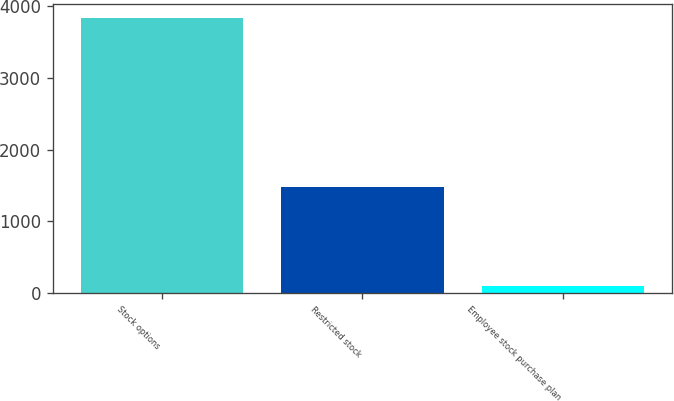Convert chart. <chart><loc_0><loc_0><loc_500><loc_500><bar_chart><fcel>Stock options<fcel>Restricted stock<fcel>Employee stock purchase plan<nl><fcel>3837<fcel>1480<fcel>104<nl></chart> 